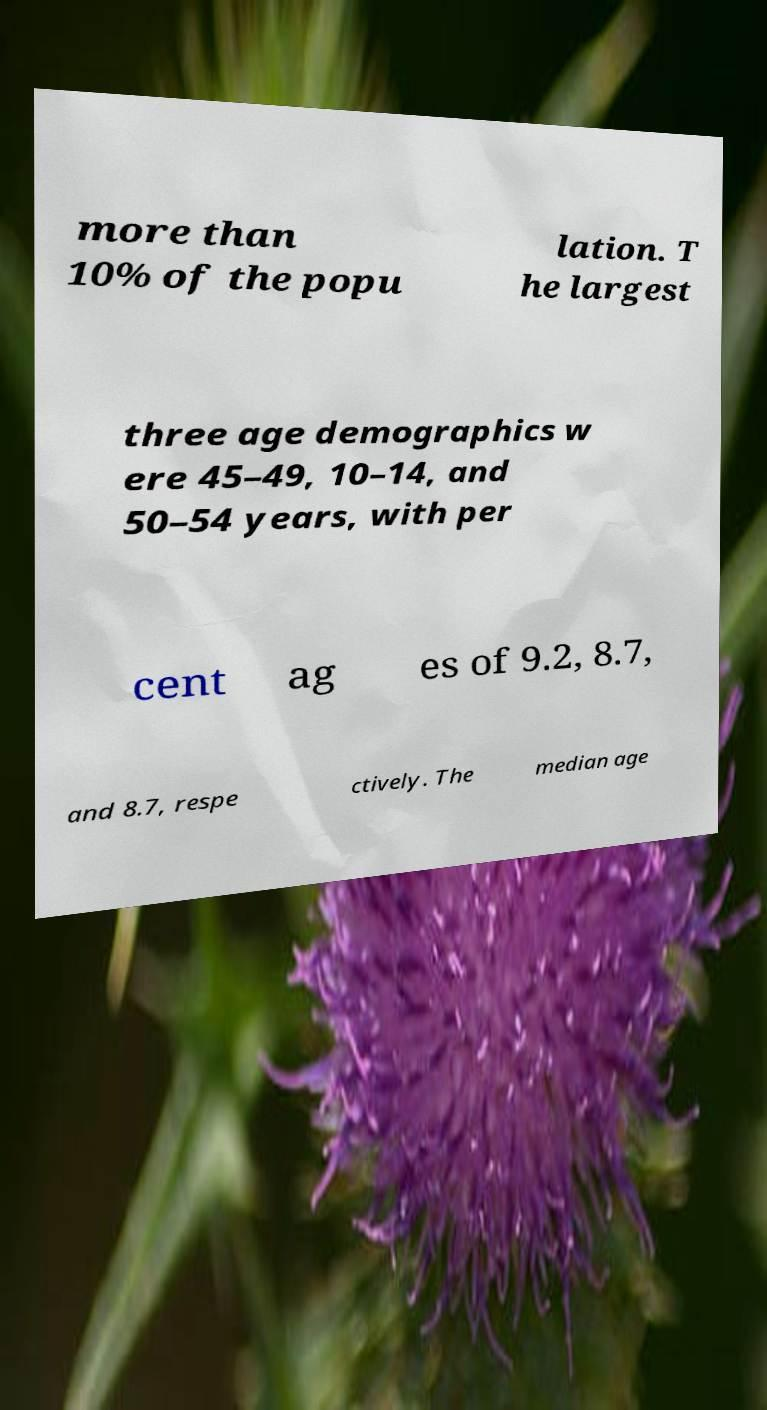I need the written content from this picture converted into text. Can you do that? more than 10% of the popu lation. T he largest three age demographics w ere 45–49, 10–14, and 50–54 years, with per cent ag es of 9.2, 8.7, and 8.7, respe ctively. The median age 